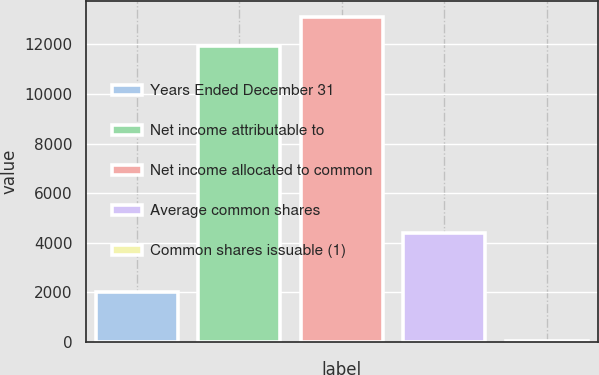Convert chart. <chart><loc_0><loc_0><loc_500><loc_500><bar_chart><fcel>Years Ended December 31<fcel>Net income attributable to<fcel>Net income allocated to common<fcel>Average common shares<fcel>Common shares issuable (1)<nl><fcel>2014<fcel>11920<fcel>13108.6<fcel>4391.2<fcel>34<nl></chart> 